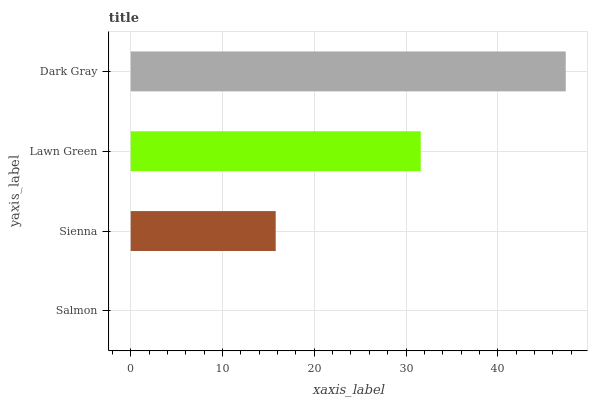Is Salmon the minimum?
Answer yes or no. Yes. Is Dark Gray the maximum?
Answer yes or no. Yes. Is Sienna the minimum?
Answer yes or no. No. Is Sienna the maximum?
Answer yes or no. No. Is Sienna greater than Salmon?
Answer yes or no. Yes. Is Salmon less than Sienna?
Answer yes or no. Yes. Is Salmon greater than Sienna?
Answer yes or no. No. Is Sienna less than Salmon?
Answer yes or no. No. Is Lawn Green the high median?
Answer yes or no. Yes. Is Sienna the low median?
Answer yes or no. Yes. Is Dark Gray the high median?
Answer yes or no. No. Is Lawn Green the low median?
Answer yes or no. No. 